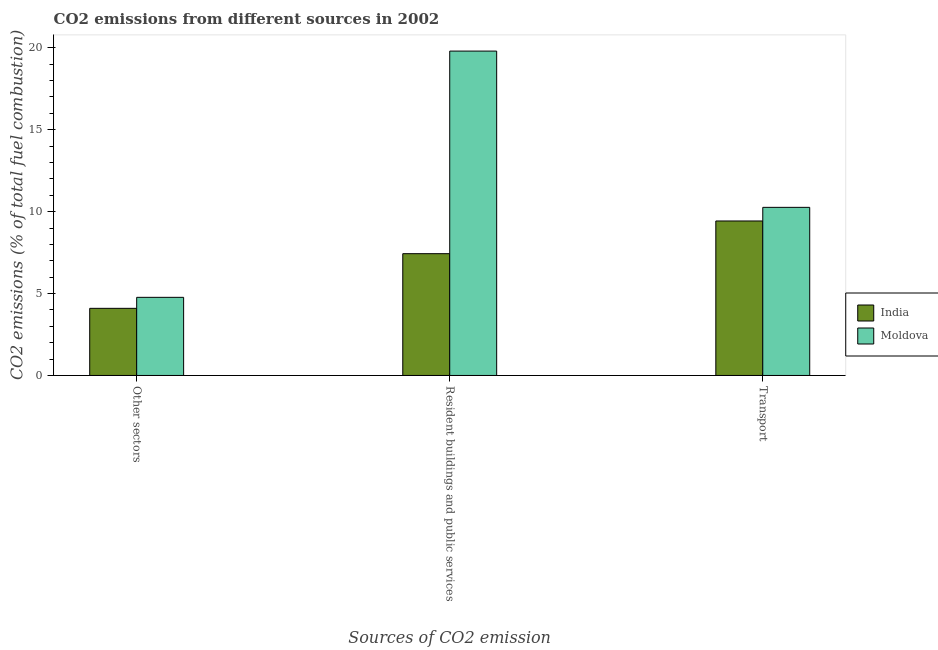Are the number of bars per tick equal to the number of legend labels?
Provide a succinct answer. Yes. How many bars are there on the 2nd tick from the right?
Give a very brief answer. 2. What is the label of the 1st group of bars from the left?
Keep it short and to the point. Other sectors. What is the percentage of co2 emissions from other sectors in Moldova?
Your answer should be compact. 4.77. Across all countries, what is the maximum percentage of co2 emissions from other sectors?
Offer a very short reply. 4.77. Across all countries, what is the minimum percentage of co2 emissions from other sectors?
Ensure brevity in your answer.  4.1. In which country was the percentage of co2 emissions from other sectors maximum?
Ensure brevity in your answer.  Moldova. What is the total percentage of co2 emissions from transport in the graph?
Give a very brief answer. 19.69. What is the difference between the percentage of co2 emissions from transport in India and that in Moldova?
Give a very brief answer. -0.83. What is the difference between the percentage of co2 emissions from resident buildings and public services in Moldova and the percentage of co2 emissions from transport in India?
Provide a succinct answer. 10.37. What is the average percentage of co2 emissions from transport per country?
Offer a very short reply. 9.84. What is the difference between the percentage of co2 emissions from other sectors and percentage of co2 emissions from resident buildings and public services in Moldova?
Your response must be concise. -15.03. In how many countries, is the percentage of co2 emissions from transport greater than 11 %?
Provide a succinct answer. 0. What is the ratio of the percentage of co2 emissions from transport in Moldova to that in India?
Make the answer very short. 1.09. Is the percentage of co2 emissions from resident buildings and public services in India less than that in Moldova?
Provide a succinct answer. Yes. Is the difference between the percentage of co2 emissions from resident buildings and public services in Moldova and India greater than the difference between the percentage of co2 emissions from other sectors in Moldova and India?
Ensure brevity in your answer.  Yes. What is the difference between the highest and the second highest percentage of co2 emissions from other sectors?
Keep it short and to the point. 0.67. What is the difference between the highest and the lowest percentage of co2 emissions from transport?
Your answer should be compact. 0.83. In how many countries, is the percentage of co2 emissions from resident buildings and public services greater than the average percentage of co2 emissions from resident buildings and public services taken over all countries?
Make the answer very short. 1. How many bars are there?
Provide a short and direct response. 6. Are all the bars in the graph horizontal?
Keep it short and to the point. No. Are the values on the major ticks of Y-axis written in scientific E-notation?
Ensure brevity in your answer.  No. How many legend labels are there?
Provide a succinct answer. 2. How are the legend labels stacked?
Your response must be concise. Vertical. What is the title of the graph?
Offer a terse response. CO2 emissions from different sources in 2002. Does "East Asia (developing only)" appear as one of the legend labels in the graph?
Your answer should be very brief. No. What is the label or title of the X-axis?
Offer a terse response. Sources of CO2 emission. What is the label or title of the Y-axis?
Your answer should be very brief. CO2 emissions (% of total fuel combustion). What is the CO2 emissions (% of total fuel combustion) of India in Other sectors?
Provide a succinct answer. 4.1. What is the CO2 emissions (% of total fuel combustion) in Moldova in Other sectors?
Offer a very short reply. 4.77. What is the CO2 emissions (% of total fuel combustion) in India in Resident buildings and public services?
Your response must be concise. 7.43. What is the CO2 emissions (% of total fuel combustion) in Moldova in Resident buildings and public services?
Keep it short and to the point. 19.8. What is the CO2 emissions (% of total fuel combustion) of India in Transport?
Offer a terse response. 9.43. What is the CO2 emissions (% of total fuel combustion) in Moldova in Transport?
Your answer should be very brief. 10.26. Across all Sources of CO2 emission, what is the maximum CO2 emissions (% of total fuel combustion) in India?
Your response must be concise. 9.43. Across all Sources of CO2 emission, what is the maximum CO2 emissions (% of total fuel combustion) of Moldova?
Your response must be concise. 19.8. Across all Sources of CO2 emission, what is the minimum CO2 emissions (% of total fuel combustion) of India?
Your answer should be very brief. 4.1. Across all Sources of CO2 emission, what is the minimum CO2 emissions (% of total fuel combustion) in Moldova?
Your answer should be compact. 4.77. What is the total CO2 emissions (% of total fuel combustion) of India in the graph?
Your response must be concise. 20.96. What is the total CO2 emissions (% of total fuel combustion) in Moldova in the graph?
Give a very brief answer. 34.83. What is the difference between the CO2 emissions (% of total fuel combustion) of India in Other sectors and that in Resident buildings and public services?
Keep it short and to the point. -3.34. What is the difference between the CO2 emissions (% of total fuel combustion) of Moldova in Other sectors and that in Resident buildings and public services?
Your response must be concise. -15.03. What is the difference between the CO2 emissions (% of total fuel combustion) in India in Other sectors and that in Transport?
Provide a succinct answer. -5.33. What is the difference between the CO2 emissions (% of total fuel combustion) of Moldova in Other sectors and that in Transport?
Offer a terse response. -5.49. What is the difference between the CO2 emissions (% of total fuel combustion) of India in Resident buildings and public services and that in Transport?
Keep it short and to the point. -2. What is the difference between the CO2 emissions (% of total fuel combustion) in Moldova in Resident buildings and public services and that in Transport?
Provide a short and direct response. 9.54. What is the difference between the CO2 emissions (% of total fuel combustion) in India in Other sectors and the CO2 emissions (% of total fuel combustion) in Moldova in Resident buildings and public services?
Provide a succinct answer. -15.7. What is the difference between the CO2 emissions (% of total fuel combustion) in India in Other sectors and the CO2 emissions (% of total fuel combustion) in Moldova in Transport?
Your answer should be very brief. -6.16. What is the difference between the CO2 emissions (% of total fuel combustion) of India in Resident buildings and public services and the CO2 emissions (% of total fuel combustion) of Moldova in Transport?
Make the answer very short. -2.83. What is the average CO2 emissions (% of total fuel combustion) of India per Sources of CO2 emission?
Offer a very short reply. 6.99. What is the average CO2 emissions (% of total fuel combustion) of Moldova per Sources of CO2 emission?
Provide a succinct answer. 11.61. What is the difference between the CO2 emissions (% of total fuel combustion) of India and CO2 emissions (% of total fuel combustion) of Moldova in Other sectors?
Your response must be concise. -0.67. What is the difference between the CO2 emissions (% of total fuel combustion) of India and CO2 emissions (% of total fuel combustion) of Moldova in Resident buildings and public services?
Keep it short and to the point. -12.37. What is the difference between the CO2 emissions (% of total fuel combustion) of India and CO2 emissions (% of total fuel combustion) of Moldova in Transport?
Your answer should be very brief. -0.83. What is the ratio of the CO2 emissions (% of total fuel combustion) in India in Other sectors to that in Resident buildings and public services?
Offer a terse response. 0.55. What is the ratio of the CO2 emissions (% of total fuel combustion) in Moldova in Other sectors to that in Resident buildings and public services?
Offer a terse response. 0.24. What is the ratio of the CO2 emissions (% of total fuel combustion) in India in Other sectors to that in Transport?
Make the answer very short. 0.43. What is the ratio of the CO2 emissions (% of total fuel combustion) of Moldova in Other sectors to that in Transport?
Your answer should be very brief. 0.46. What is the ratio of the CO2 emissions (% of total fuel combustion) of India in Resident buildings and public services to that in Transport?
Ensure brevity in your answer.  0.79. What is the ratio of the CO2 emissions (% of total fuel combustion) of Moldova in Resident buildings and public services to that in Transport?
Ensure brevity in your answer.  1.93. What is the difference between the highest and the second highest CO2 emissions (% of total fuel combustion) in India?
Provide a succinct answer. 2. What is the difference between the highest and the second highest CO2 emissions (% of total fuel combustion) in Moldova?
Offer a terse response. 9.54. What is the difference between the highest and the lowest CO2 emissions (% of total fuel combustion) of India?
Your answer should be very brief. 5.33. What is the difference between the highest and the lowest CO2 emissions (% of total fuel combustion) of Moldova?
Keep it short and to the point. 15.03. 